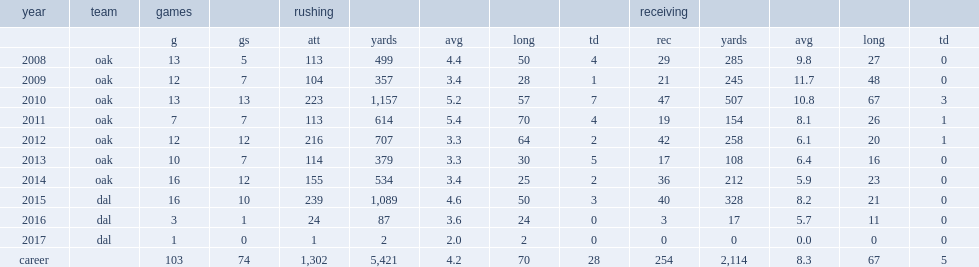How many rushing yards did darren mcfadden get in 2015? 1089.0. 